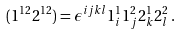Convert formula to latex. <formula><loc_0><loc_0><loc_500><loc_500>( 1 ^ { 1 2 } 2 ^ { 1 2 } ) = \epsilon ^ { i j k l } 1 ^ { 1 } _ { i } 1 ^ { 2 } _ { j } 2 ^ { 1 } _ { k } 2 ^ { 2 } _ { l } \, .</formula> 